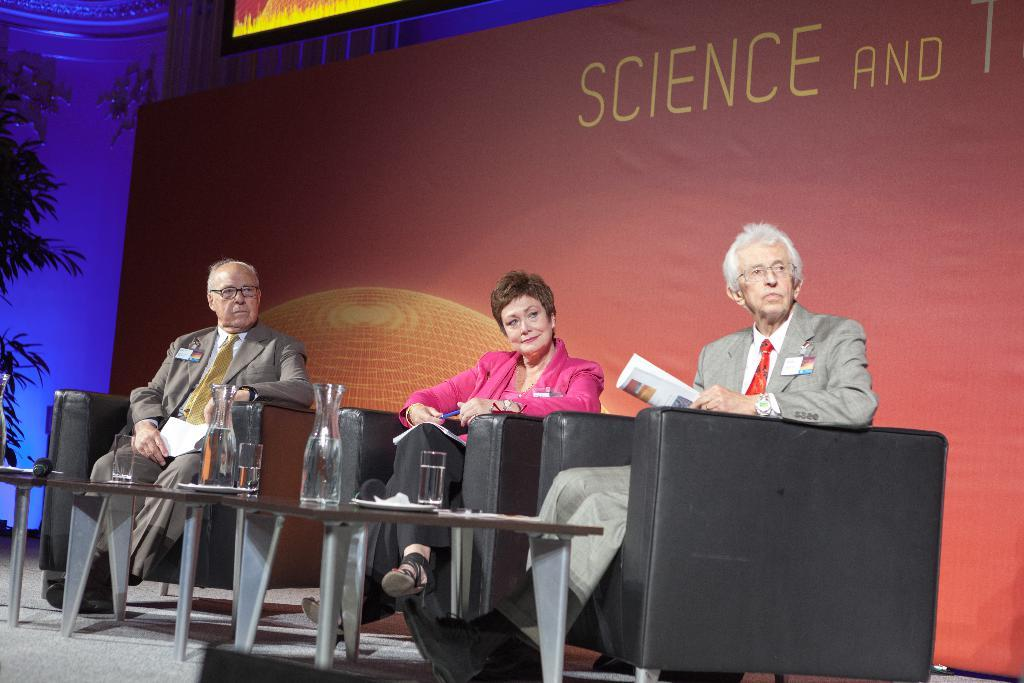How many people are sitting in the image? There are three persons sitting on chairs in the image. What objects can be seen on the tables? There are glasses with water on the tables. What device is present in the image for amplifying sound? There is a microphone (mike) in the image. What can be seen in the background of the image? There is a board (aboard) in the background of the image. What type of swing can be seen in the image? There is no swing present in the image. What kind of vessel is being used to serve the water in the glasses? The provided facts do not mention any vessel used to serve the water in the glasses; only the glasses themselves are mentioned. 